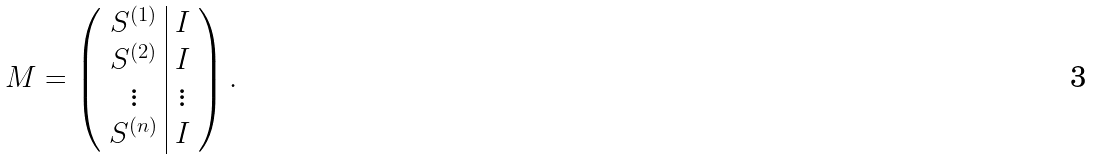<formula> <loc_0><loc_0><loc_500><loc_500>M = \left ( \begin{array} { c | c } S ^ { ( 1 ) } & I \\ S ^ { ( 2 ) } & I \\ \vdots & \vdots \\ S ^ { ( n ) } & I \end{array} \right ) .</formula> 